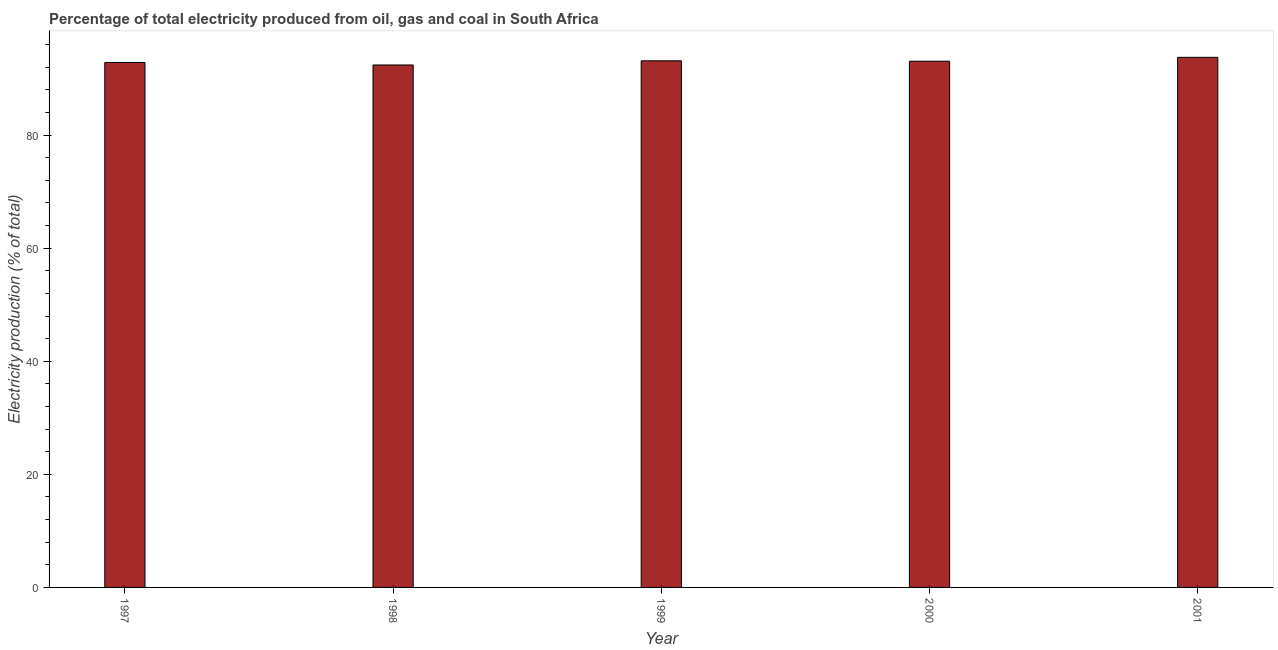Does the graph contain any zero values?
Ensure brevity in your answer.  No. Does the graph contain grids?
Your answer should be compact. No. What is the title of the graph?
Offer a terse response. Percentage of total electricity produced from oil, gas and coal in South Africa. What is the label or title of the X-axis?
Offer a very short reply. Year. What is the label or title of the Y-axis?
Offer a terse response. Electricity production (% of total). What is the electricity production in 1998?
Your response must be concise. 92.4. Across all years, what is the maximum electricity production?
Provide a succinct answer. 93.75. Across all years, what is the minimum electricity production?
Ensure brevity in your answer.  92.4. In which year was the electricity production minimum?
Offer a terse response. 1998. What is the sum of the electricity production?
Ensure brevity in your answer.  465.18. What is the difference between the electricity production in 1997 and 2001?
Make the answer very short. -0.92. What is the average electricity production per year?
Your answer should be compact. 93.04. What is the median electricity production?
Your response must be concise. 93.06. Do a majority of the years between 2000 and 1997 (inclusive) have electricity production greater than 20 %?
Offer a very short reply. Yes. What is the ratio of the electricity production in 1999 to that in 2001?
Give a very brief answer. 0.99. Is the electricity production in 1998 less than that in 2000?
Your answer should be compact. Yes. Is the difference between the electricity production in 1997 and 2000 greater than the difference between any two years?
Provide a succinct answer. No. What is the difference between the highest and the second highest electricity production?
Provide a short and direct response. 0.61. Is the sum of the electricity production in 1997 and 2000 greater than the maximum electricity production across all years?
Your response must be concise. Yes. What is the difference between the highest and the lowest electricity production?
Offer a very short reply. 1.35. How many bars are there?
Provide a short and direct response. 5. Are all the bars in the graph horizontal?
Give a very brief answer. No. How many years are there in the graph?
Your response must be concise. 5. What is the Electricity production (% of total) of 1997?
Keep it short and to the point. 92.84. What is the Electricity production (% of total) in 1998?
Your response must be concise. 92.4. What is the Electricity production (% of total) of 1999?
Keep it short and to the point. 93.13. What is the Electricity production (% of total) in 2000?
Provide a succinct answer. 93.06. What is the Electricity production (% of total) of 2001?
Offer a very short reply. 93.75. What is the difference between the Electricity production (% of total) in 1997 and 1998?
Offer a terse response. 0.44. What is the difference between the Electricity production (% of total) in 1997 and 1999?
Offer a very short reply. -0.3. What is the difference between the Electricity production (% of total) in 1997 and 2000?
Offer a terse response. -0.23. What is the difference between the Electricity production (% of total) in 1997 and 2001?
Provide a short and direct response. -0.91. What is the difference between the Electricity production (% of total) in 1998 and 1999?
Provide a short and direct response. -0.74. What is the difference between the Electricity production (% of total) in 1998 and 2000?
Provide a short and direct response. -0.66. What is the difference between the Electricity production (% of total) in 1998 and 2001?
Keep it short and to the point. -1.35. What is the difference between the Electricity production (% of total) in 1999 and 2000?
Your answer should be compact. 0.07. What is the difference between the Electricity production (% of total) in 1999 and 2001?
Make the answer very short. -0.62. What is the difference between the Electricity production (% of total) in 2000 and 2001?
Your answer should be compact. -0.69. What is the ratio of the Electricity production (% of total) in 1997 to that in 1998?
Your answer should be very brief. 1. What is the ratio of the Electricity production (% of total) in 1997 to that in 2000?
Offer a very short reply. 1. What is the ratio of the Electricity production (% of total) in 1998 to that in 1999?
Provide a succinct answer. 0.99. What is the ratio of the Electricity production (% of total) in 1998 to that in 2001?
Give a very brief answer. 0.99. What is the ratio of the Electricity production (% of total) in 1999 to that in 2001?
Keep it short and to the point. 0.99. 